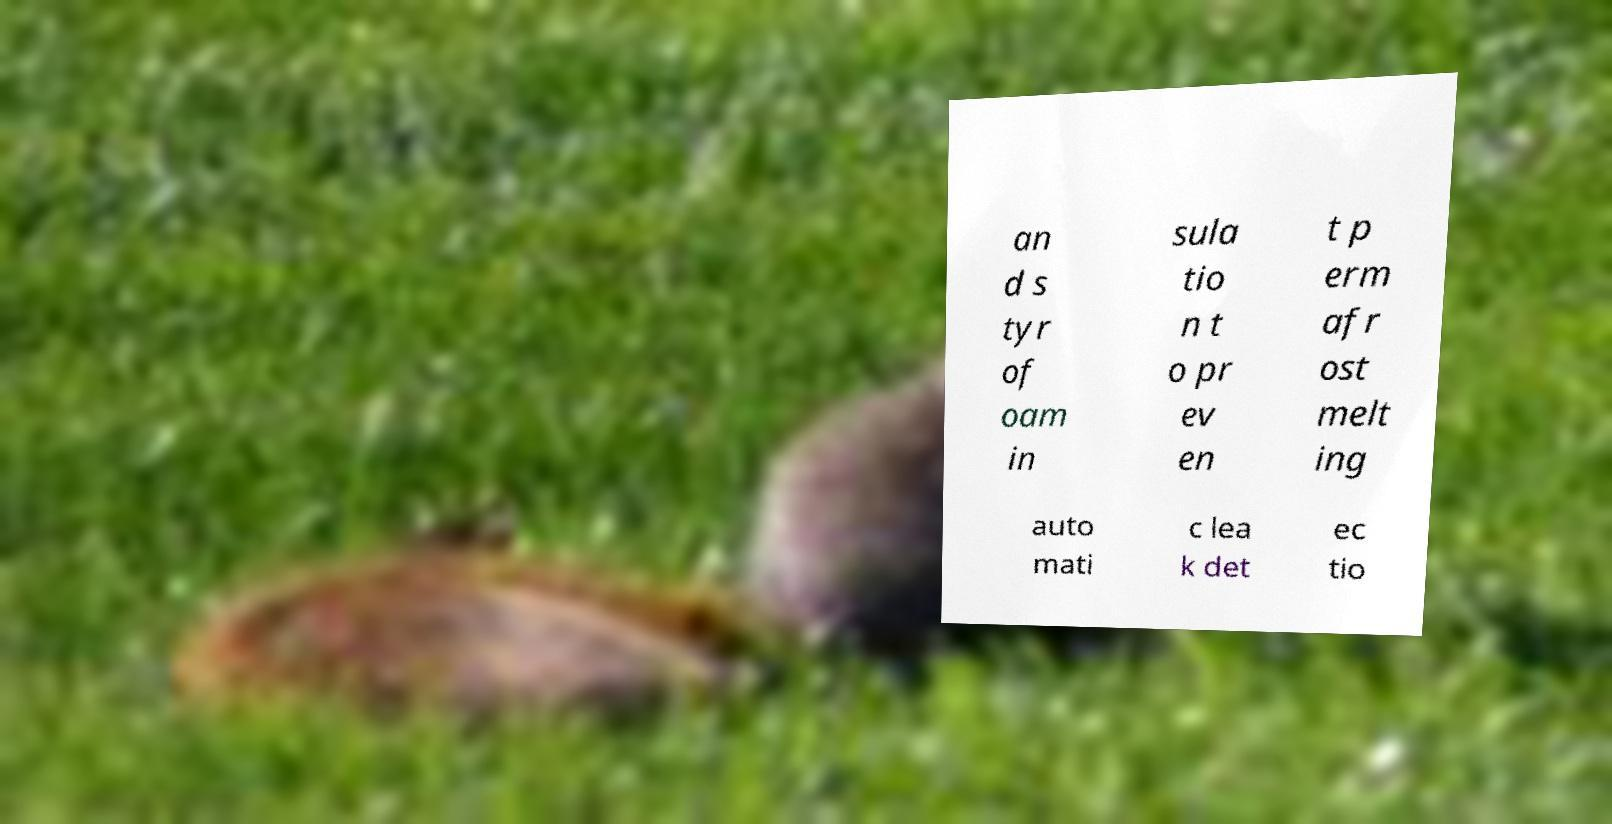For documentation purposes, I need the text within this image transcribed. Could you provide that? an d s tyr of oam in sula tio n t o pr ev en t p erm afr ost melt ing auto mati c lea k det ec tio 